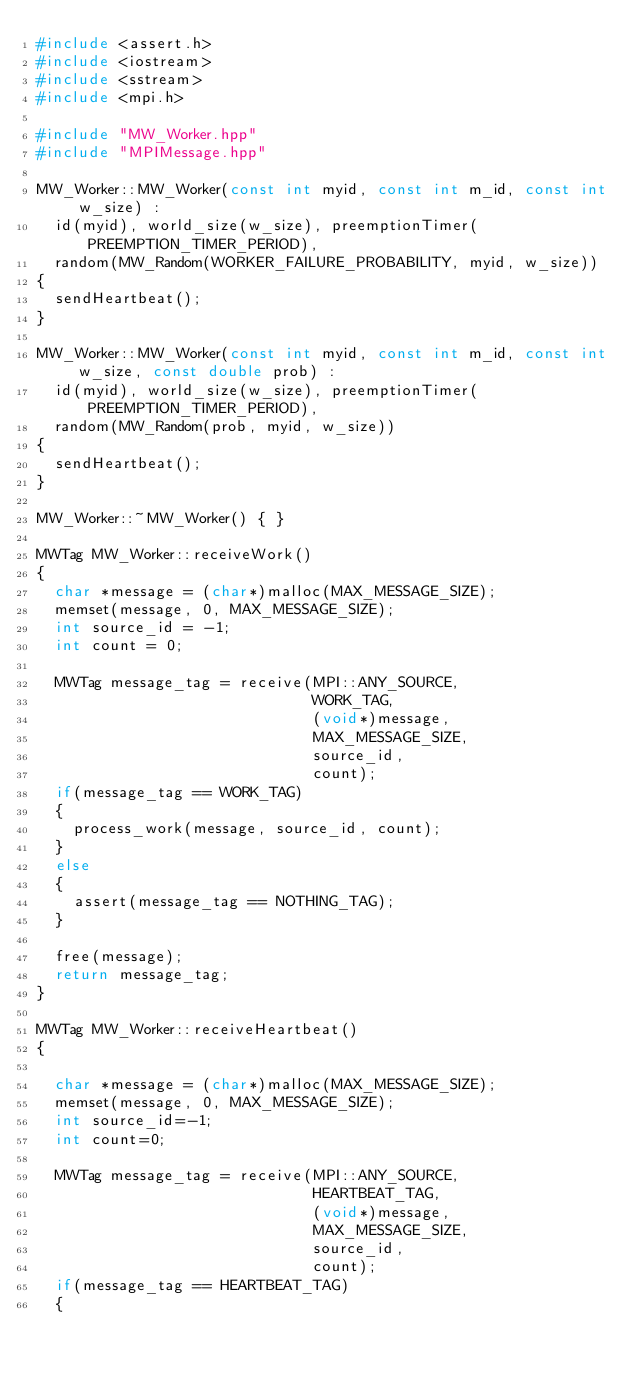<code> <loc_0><loc_0><loc_500><loc_500><_C++_>#include <assert.h>
#include <iostream>
#include <sstream>
#include <mpi.h>

#include "MW_Worker.hpp"
#include "MPIMessage.hpp"

MW_Worker::MW_Worker(const int myid, const int m_id, const int w_size) :
  id(myid), world_size(w_size), preemptionTimer(PREEMPTION_TIMER_PERIOD),
  random(MW_Random(WORKER_FAILURE_PROBABILITY, myid, w_size))
{
  sendHeartbeat();
}

MW_Worker::MW_Worker(const int myid, const int m_id, const int w_size, const double prob) :
  id(myid), world_size(w_size), preemptionTimer(PREEMPTION_TIMER_PERIOD),
  random(MW_Random(prob, myid, w_size))
{
  sendHeartbeat();
}

MW_Worker::~MW_Worker() { }

MWTag MW_Worker::receiveWork()
{
  char *message = (char*)malloc(MAX_MESSAGE_SIZE);
  memset(message, 0, MAX_MESSAGE_SIZE);
  int source_id = -1;
  int count = 0;

  MWTag message_tag = receive(MPI::ANY_SOURCE,
                              WORK_TAG,
                              (void*)message,
                              MAX_MESSAGE_SIZE,
                              source_id,
                              count);
  if(message_tag == WORK_TAG)
  {
    process_work(message, source_id, count);
  }
  else
  {
    assert(message_tag == NOTHING_TAG);
  }

  free(message);
  return message_tag;
}

MWTag MW_Worker::receiveHeartbeat()
{

  char *message = (char*)malloc(MAX_MESSAGE_SIZE);
  memset(message, 0, MAX_MESSAGE_SIZE);
  int source_id=-1;
  int count=0;

  MWTag message_tag = receive(MPI::ANY_SOURCE,
                              HEARTBEAT_TAG,
                              (void*)message,
                              MAX_MESSAGE_SIZE,
                              source_id,
                              count);
  if(message_tag == HEARTBEAT_TAG)
  {</code> 